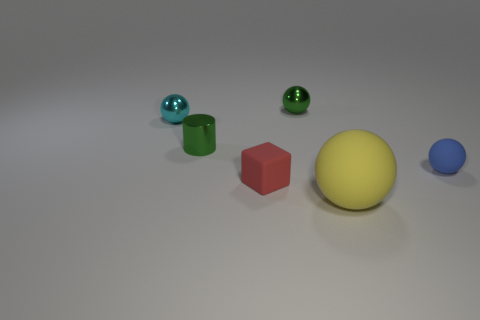Can you tell me what shapes are present in the image and their colors? Certainly! The image depicts a collection of geometric figures, including a green cylinder, a red cube, a yellow sphere, and a blue capsule. In addition, there are two spheres that share the same green hue as the cylinder. 